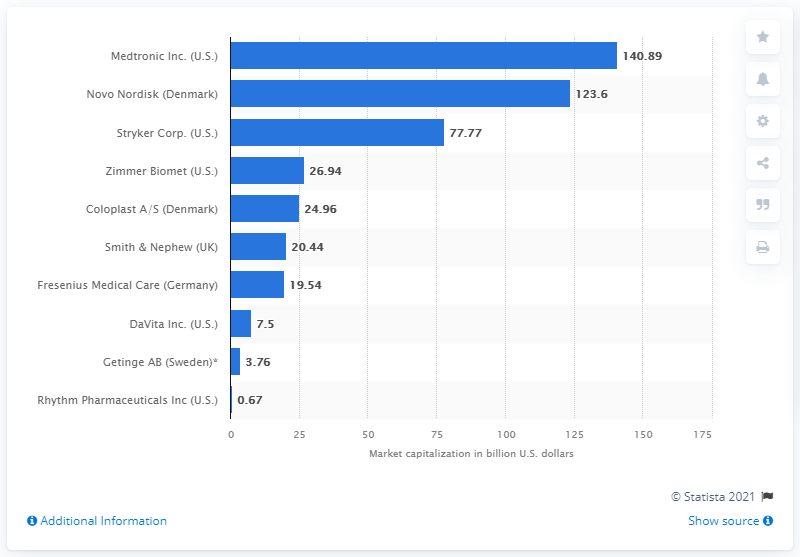Specify some key components in this picture. On October 9, 2019, Novo Nordisk's market capitalization was approximately 123.6... 